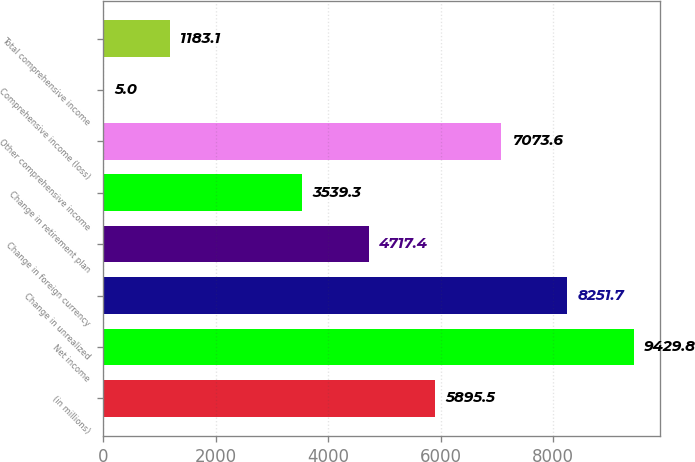Convert chart to OTSL. <chart><loc_0><loc_0><loc_500><loc_500><bar_chart><fcel>(in millions)<fcel>Net income<fcel>Change in unrealized<fcel>Change in foreign currency<fcel>Change in retirement plan<fcel>Other comprehensive income<fcel>Comprehensive income (loss)<fcel>Total comprehensive income<nl><fcel>5895.5<fcel>9429.8<fcel>8251.7<fcel>4717.4<fcel>3539.3<fcel>7073.6<fcel>5<fcel>1183.1<nl></chart> 